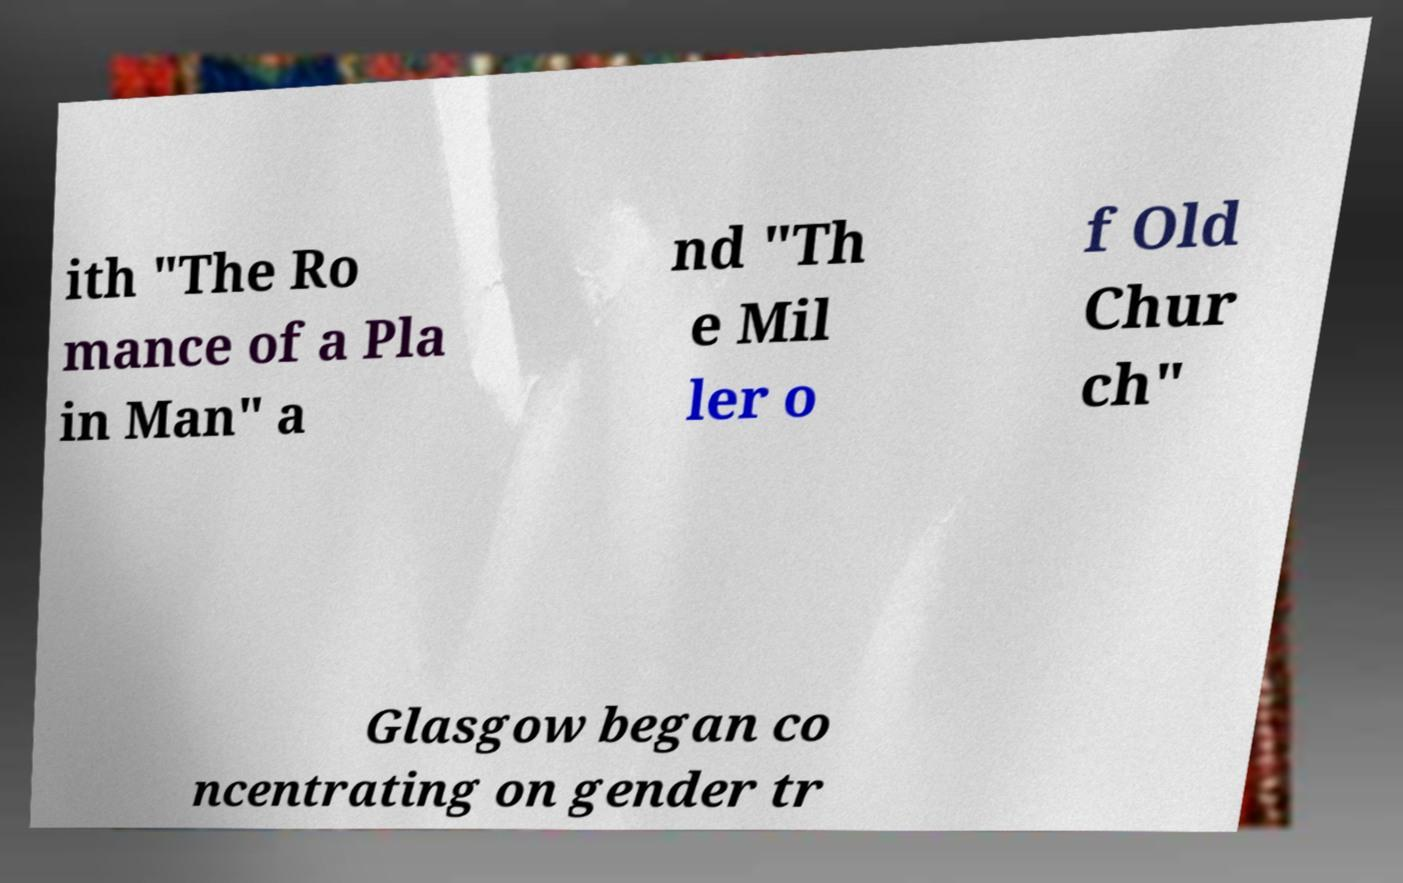Can you read and provide the text displayed in the image?This photo seems to have some interesting text. Can you extract and type it out for me? ith "The Ro mance of a Pla in Man" a nd "Th e Mil ler o f Old Chur ch" Glasgow began co ncentrating on gender tr 